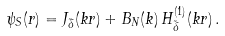Convert formula to latex. <formula><loc_0><loc_0><loc_500><loc_500>\psi _ { S } ( r ) = J _ { \tilde { \delta } } ( k r ) + B _ { N } ( k ) \, H _ { \tilde { \delta } } ^ { ( 1 ) } ( k r ) \, .</formula> 